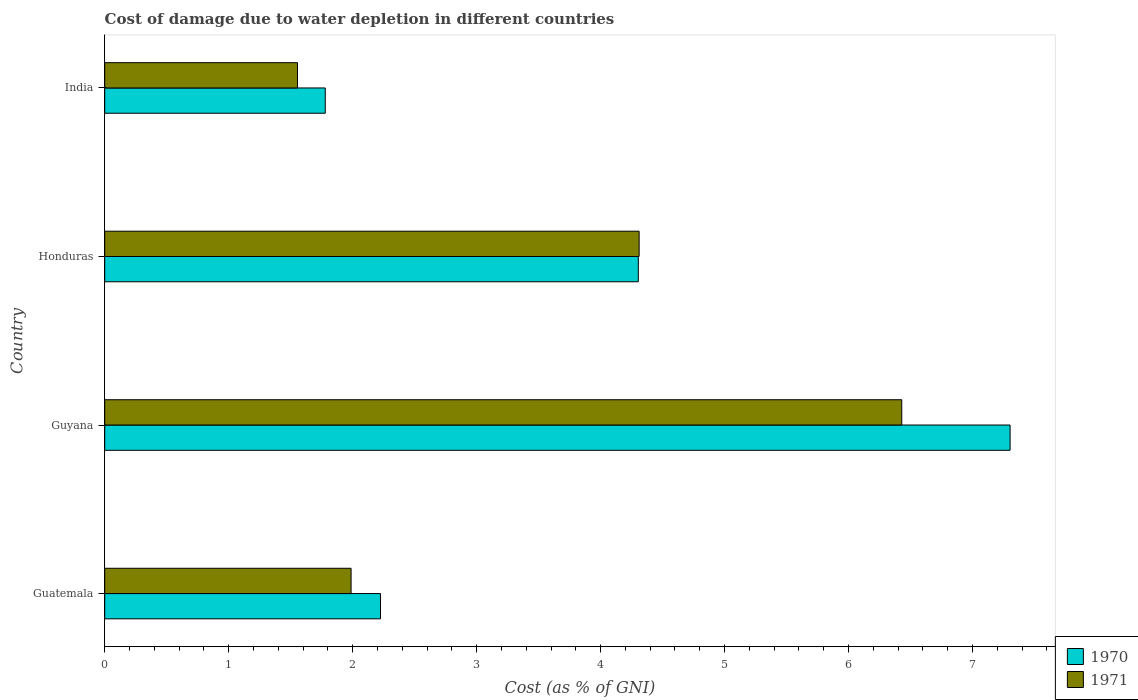How many bars are there on the 4th tick from the bottom?
Offer a very short reply. 2. What is the label of the 3rd group of bars from the top?
Provide a short and direct response. Guyana. In how many cases, is the number of bars for a given country not equal to the number of legend labels?
Keep it short and to the point. 0. What is the cost of damage caused due to water depletion in 1970 in Honduras?
Offer a terse response. 4.3. Across all countries, what is the maximum cost of damage caused due to water depletion in 1970?
Your answer should be very brief. 7.3. Across all countries, what is the minimum cost of damage caused due to water depletion in 1970?
Ensure brevity in your answer.  1.78. In which country was the cost of damage caused due to water depletion in 1971 maximum?
Provide a succinct answer. Guyana. What is the total cost of damage caused due to water depletion in 1970 in the graph?
Your answer should be very brief. 15.61. What is the difference between the cost of damage caused due to water depletion in 1970 in Guatemala and that in India?
Give a very brief answer. 0.45. What is the difference between the cost of damage caused due to water depletion in 1971 in India and the cost of damage caused due to water depletion in 1970 in Guatemala?
Offer a terse response. -0.67. What is the average cost of damage caused due to water depletion in 1971 per country?
Give a very brief answer. 3.57. What is the difference between the cost of damage caused due to water depletion in 1970 and cost of damage caused due to water depletion in 1971 in Guatemala?
Offer a terse response. 0.24. What is the ratio of the cost of damage caused due to water depletion in 1971 in Guyana to that in India?
Your answer should be compact. 4.13. Is the cost of damage caused due to water depletion in 1971 in Honduras less than that in India?
Offer a very short reply. No. What is the difference between the highest and the second highest cost of damage caused due to water depletion in 1970?
Provide a short and direct response. 3. What is the difference between the highest and the lowest cost of damage caused due to water depletion in 1970?
Offer a very short reply. 5.52. Is the sum of the cost of damage caused due to water depletion in 1970 in Guatemala and Honduras greater than the maximum cost of damage caused due to water depletion in 1971 across all countries?
Your answer should be very brief. Yes. What does the 2nd bar from the top in India represents?
Your response must be concise. 1970. What does the 1st bar from the bottom in Guyana represents?
Make the answer very short. 1970. How many bars are there?
Make the answer very short. 8. Are all the bars in the graph horizontal?
Your answer should be very brief. Yes. How many countries are there in the graph?
Provide a succinct answer. 4. What is the title of the graph?
Provide a short and direct response. Cost of damage due to water depletion in different countries. What is the label or title of the X-axis?
Offer a very short reply. Cost (as % of GNI). What is the label or title of the Y-axis?
Keep it short and to the point. Country. What is the Cost (as % of GNI) in 1970 in Guatemala?
Give a very brief answer. 2.22. What is the Cost (as % of GNI) in 1971 in Guatemala?
Offer a very short reply. 1.99. What is the Cost (as % of GNI) in 1970 in Guyana?
Your answer should be compact. 7.3. What is the Cost (as % of GNI) in 1971 in Guyana?
Provide a short and direct response. 6.43. What is the Cost (as % of GNI) in 1970 in Honduras?
Your answer should be compact. 4.3. What is the Cost (as % of GNI) of 1971 in Honduras?
Provide a succinct answer. 4.31. What is the Cost (as % of GNI) of 1970 in India?
Keep it short and to the point. 1.78. What is the Cost (as % of GNI) of 1971 in India?
Give a very brief answer. 1.55. Across all countries, what is the maximum Cost (as % of GNI) of 1970?
Offer a very short reply. 7.3. Across all countries, what is the maximum Cost (as % of GNI) of 1971?
Provide a succinct answer. 6.43. Across all countries, what is the minimum Cost (as % of GNI) of 1970?
Provide a succinct answer. 1.78. Across all countries, what is the minimum Cost (as % of GNI) of 1971?
Your answer should be compact. 1.55. What is the total Cost (as % of GNI) of 1970 in the graph?
Your answer should be compact. 15.61. What is the total Cost (as % of GNI) in 1971 in the graph?
Your response must be concise. 14.28. What is the difference between the Cost (as % of GNI) of 1970 in Guatemala and that in Guyana?
Make the answer very short. -5.08. What is the difference between the Cost (as % of GNI) of 1971 in Guatemala and that in Guyana?
Your answer should be compact. -4.44. What is the difference between the Cost (as % of GNI) in 1970 in Guatemala and that in Honduras?
Offer a terse response. -2.08. What is the difference between the Cost (as % of GNI) of 1971 in Guatemala and that in Honduras?
Your answer should be very brief. -2.32. What is the difference between the Cost (as % of GNI) in 1970 in Guatemala and that in India?
Provide a short and direct response. 0.45. What is the difference between the Cost (as % of GNI) in 1971 in Guatemala and that in India?
Your answer should be very brief. 0.43. What is the difference between the Cost (as % of GNI) of 1970 in Guyana and that in Honduras?
Ensure brevity in your answer.  3. What is the difference between the Cost (as % of GNI) of 1971 in Guyana and that in Honduras?
Give a very brief answer. 2.12. What is the difference between the Cost (as % of GNI) in 1970 in Guyana and that in India?
Offer a very short reply. 5.52. What is the difference between the Cost (as % of GNI) of 1971 in Guyana and that in India?
Your response must be concise. 4.87. What is the difference between the Cost (as % of GNI) of 1970 in Honduras and that in India?
Provide a succinct answer. 2.53. What is the difference between the Cost (as % of GNI) in 1971 in Honduras and that in India?
Keep it short and to the point. 2.76. What is the difference between the Cost (as % of GNI) in 1970 in Guatemala and the Cost (as % of GNI) in 1971 in Guyana?
Provide a short and direct response. -4.2. What is the difference between the Cost (as % of GNI) in 1970 in Guatemala and the Cost (as % of GNI) in 1971 in Honduras?
Your response must be concise. -2.09. What is the difference between the Cost (as % of GNI) in 1970 in Guatemala and the Cost (as % of GNI) in 1971 in India?
Provide a short and direct response. 0.67. What is the difference between the Cost (as % of GNI) in 1970 in Guyana and the Cost (as % of GNI) in 1971 in Honduras?
Your answer should be compact. 2.99. What is the difference between the Cost (as % of GNI) of 1970 in Guyana and the Cost (as % of GNI) of 1971 in India?
Give a very brief answer. 5.75. What is the difference between the Cost (as % of GNI) in 1970 in Honduras and the Cost (as % of GNI) in 1971 in India?
Keep it short and to the point. 2.75. What is the average Cost (as % of GNI) of 1970 per country?
Your answer should be very brief. 3.9. What is the average Cost (as % of GNI) of 1971 per country?
Provide a succinct answer. 3.57. What is the difference between the Cost (as % of GNI) in 1970 and Cost (as % of GNI) in 1971 in Guatemala?
Ensure brevity in your answer.  0.24. What is the difference between the Cost (as % of GNI) of 1970 and Cost (as % of GNI) of 1971 in Guyana?
Provide a succinct answer. 0.87. What is the difference between the Cost (as % of GNI) of 1970 and Cost (as % of GNI) of 1971 in Honduras?
Your answer should be very brief. -0.01. What is the difference between the Cost (as % of GNI) of 1970 and Cost (as % of GNI) of 1971 in India?
Offer a very short reply. 0.22. What is the ratio of the Cost (as % of GNI) of 1970 in Guatemala to that in Guyana?
Your answer should be compact. 0.3. What is the ratio of the Cost (as % of GNI) of 1971 in Guatemala to that in Guyana?
Offer a terse response. 0.31. What is the ratio of the Cost (as % of GNI) of 1970 in Guatemala to that in Honduras?
Provide a succinct answer. 0.52. What is the ratio of the Cost (as % of GNI) in 1971 in Guatemala to that in Honduras?
Keep it short and to the point. 0.46. What is the ratio of the Cost (as % of GNI) of 1970 in Guatemala to that in India?
Your response must be concise. 1.25. What is the ratio of the Cost (as % of GNI) of 1971 in Guatemala to that in India?
Your answer should be very brief. 1.28. What is the ratio of the Cost (as % of GNI) in 1970 in Guyana to that in Honduras?
Ensure brevity in your answer.  1.7. What is the ratio of the Cost (as % of GNI) in 1971 in Guyana to that in Honduras?
Keep it short and to the point. 1.49. What is the ratio of the Cost (as % of GNI) in 1970 in Guyana to that in India?
Ensure brevity in your answer.  4.11. What is the ratio of the Cost (as % of GNI) of 1971 in Guyana to that in India?
Offer a terse response. 4.13. What is the ratio of the Cost (as % of GNI) in 1970 in Honduras to that in India?
Give a very brief answer. 2.42. What is the ratio of the Cost (as % of GNI) of 1971 in Honduras to that in India?
Keep it short and to the point. 2.77. What is the difference between the highest and the second highest Cost (as % of GNI) in 1970?
Give a very brief answer. 3. What is the difference between the highest and the second highest Cost (as % of GNI) in 1971?
Provide a short and direct response. 2.12. What is the difference between the highest and the lowest Cost (as % of GNI) in 1970?
Provide a succinct answer. 5.52. What is the difference between the highest and the lowest Cost (as % of GNI) of 1971?
Give a very brief answer. 4.87. 